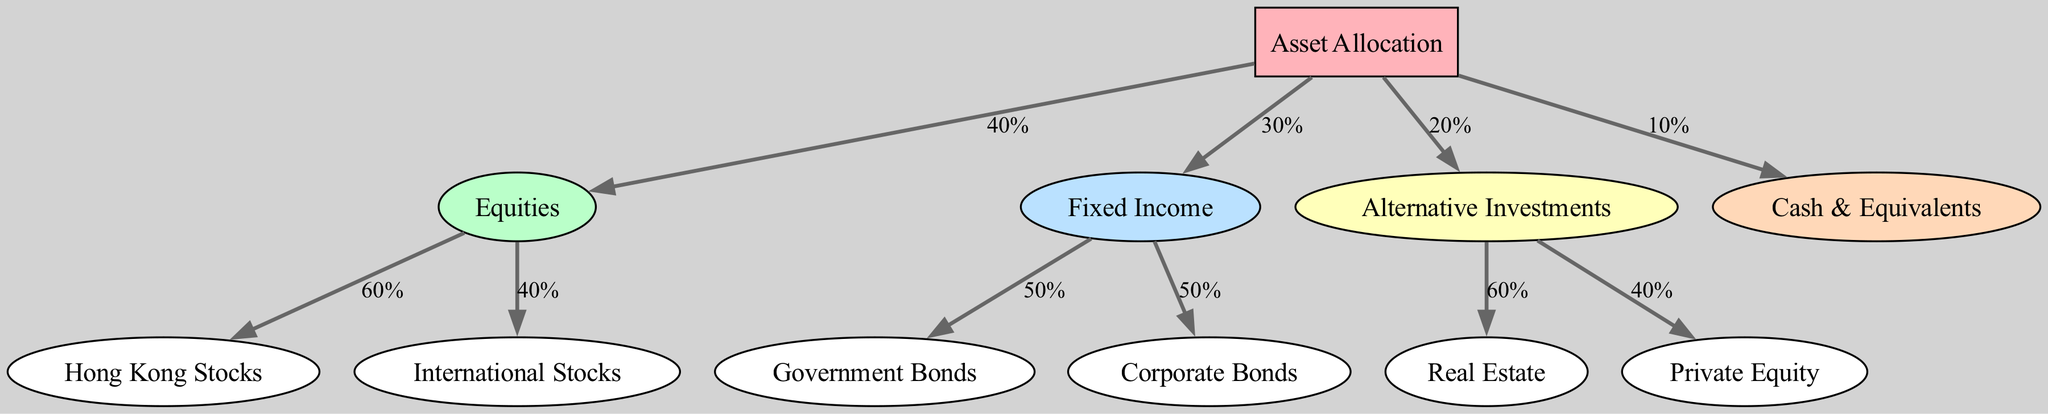What is the total percentage allocated to equities? The diagram shows that equities have a 40% allocation.
Answer: 40% How many types of fixed income investments are identified? There are two types of fixed income investments shown: government bonds and corporate bonds.
Answer: 2 What is the percentage allocation for alternative investments? The diagram indicates that alternative investments have a 20% allocation.
Answer: 20% What percentage of equities is allocated to international stocks? The diagram states that 40% of equities is allocated to international stocks.
Answer: 40% What is the relationship between fixed income and cash & equivalents? Fixed income is a separate category with a 30% allocation, while cash & equivalents have a 10% allocation; they are linked through the main asset allocation node.
Answer: They are both part of the overall asset allocation What percentage of fixed income is allocated to corporate bonds? According to the diagram, corporate bonds receive a 50% allocation from fixed income.
Answer: 50% How many total edges are present in the diagram? By counting the connections from nodes to nodes, there are 10 edges in total.
Answer: 10 What is the allocation of cash & equivalents relative to the total asset allocation? Cash & equivalents constitute a 10% portion of the total asset allocation.
Answer: 10% Which asset class has the highest percentage allocation, according to the diagram? Equities, with a 40% allocation, have the highest percentage among the asset classes presented.
Answer: Equities 